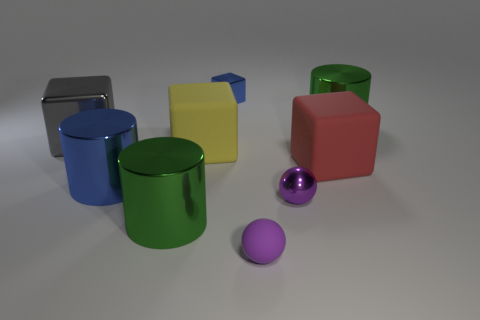Subtract 1 cubes. How many cubes are left? 3 Subtract all blocks. How many objects are left? 5 Add 8 small purple balls. How many small purple balls exist? 10 Subtract 0 cyan spheres. How many objects are left? 9 Subtract all tiny purple rubber objects. Subtract all large green cylinders. How many objects are left? 6 Add 9 big blue metallic cylinders. How many big blue metallic cylinders are left? 10 